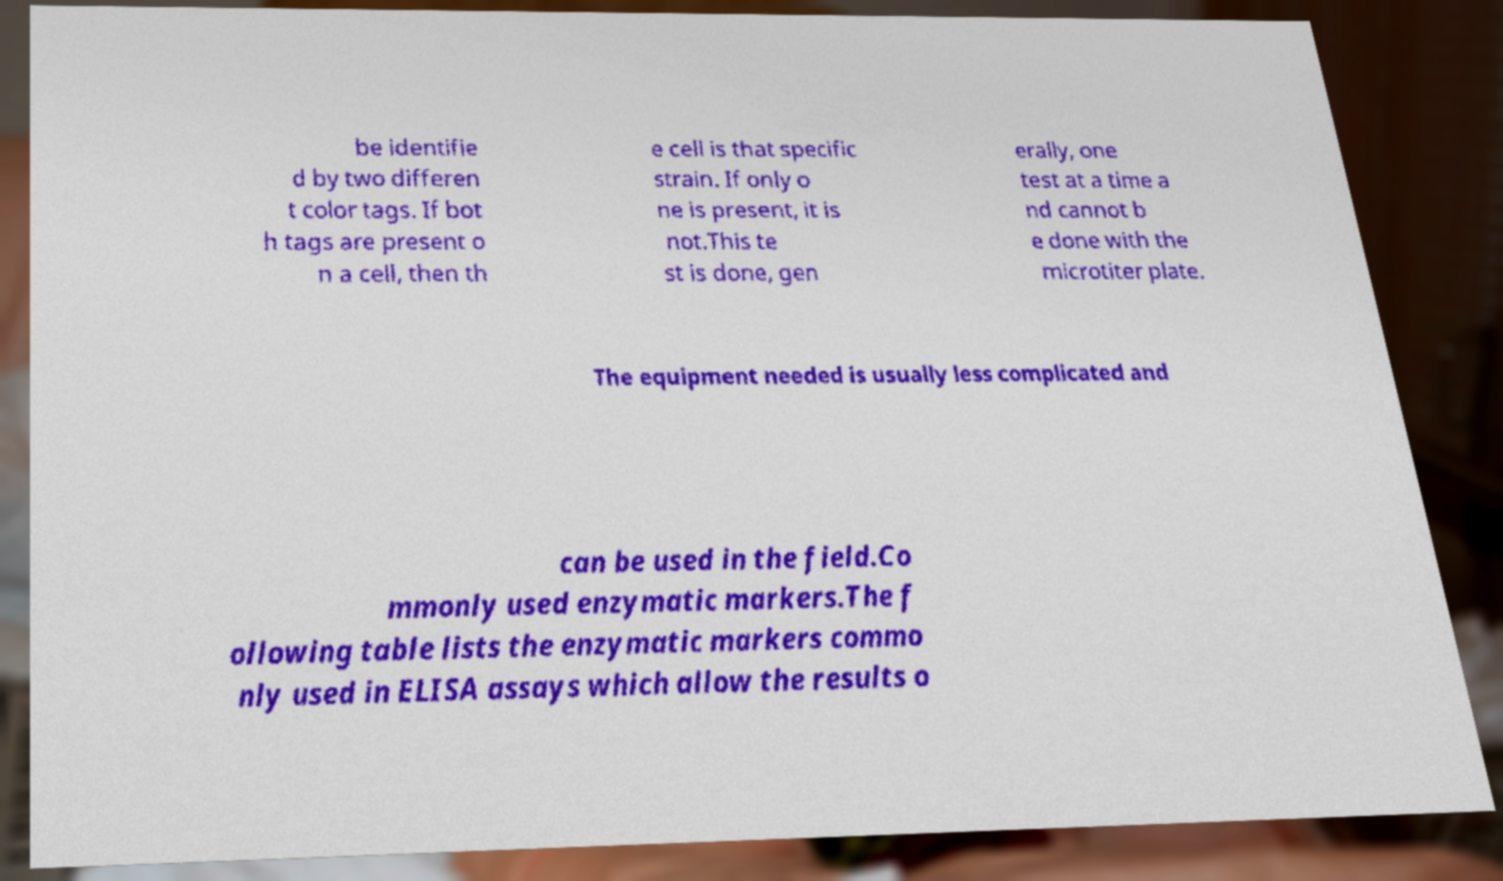What messages or text are displayed in this image? I need them in a readable, typed format. be identifie d by two differen t color tags. If bot h tags are present o n a cell, then th e cell is that specific strain. If only o ne is present, it is not.This te st is done, gen erally, one test at a time a nd cannot b e done with the microtiter plate. The equipment needed is usually less complicated and can be used in the field.Co mmonly used enzymatic markers.The f ollowing table lists the enzymatic markers commo nly used in ELISA assays which allow the results o 